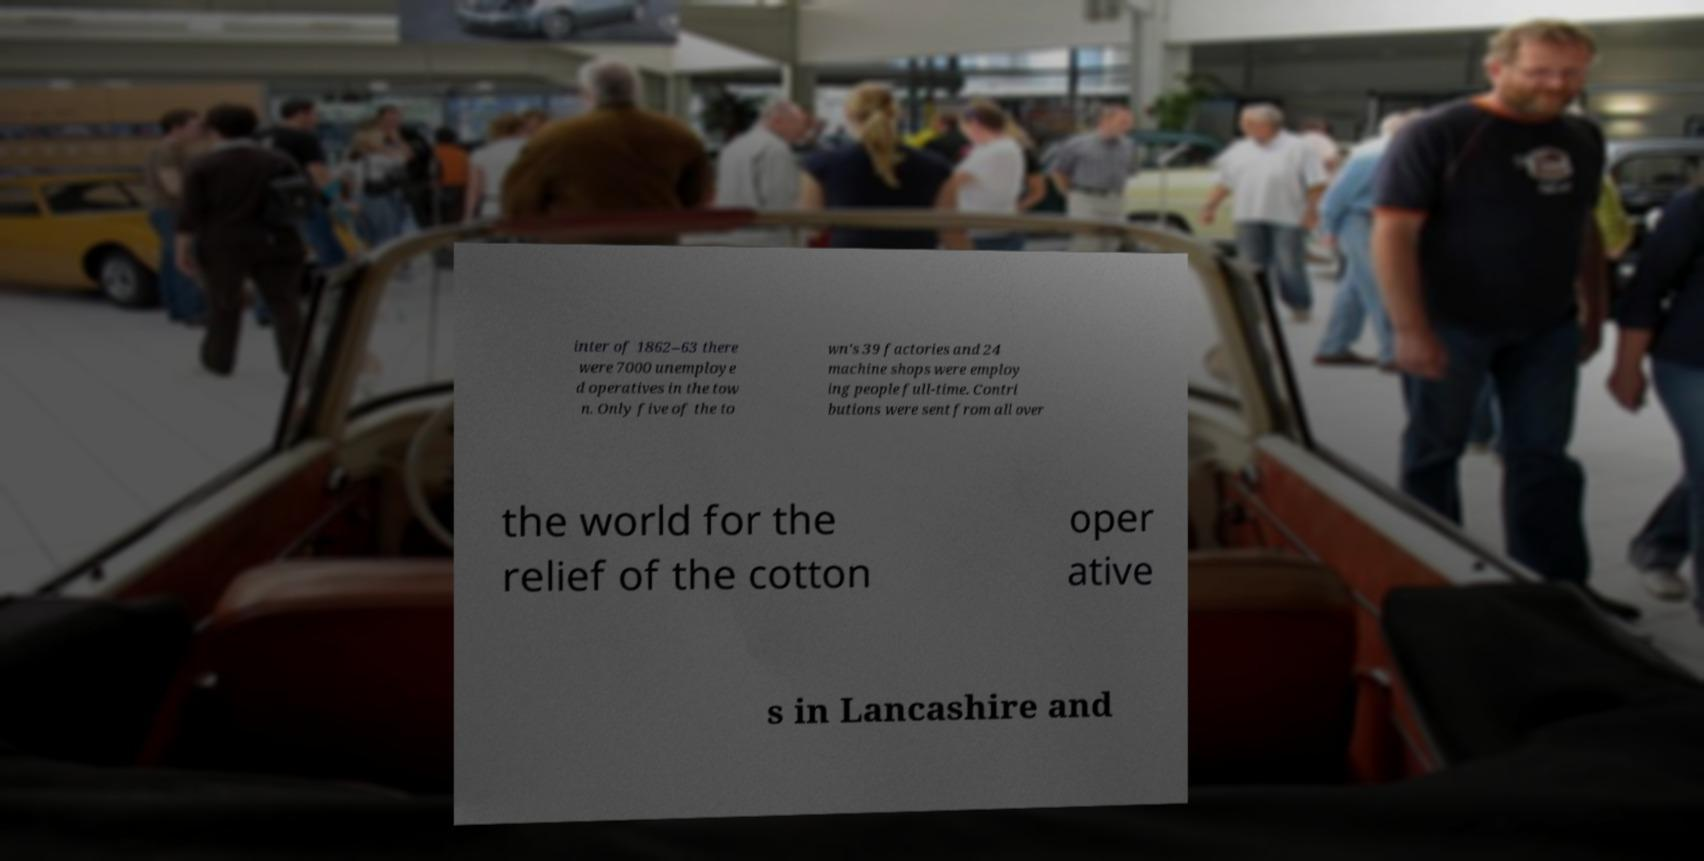Can you accurately transcribe the text from the provided image for me? inter of 1862–63 there were 7000 unemploye d operatives in the tow n. Only five of the to wn's 39 factories and 24 machine shops were employ ing people full-time. Contri butions were sent from all over the world for the relief of the cotton oper ative s in Lancashire and 